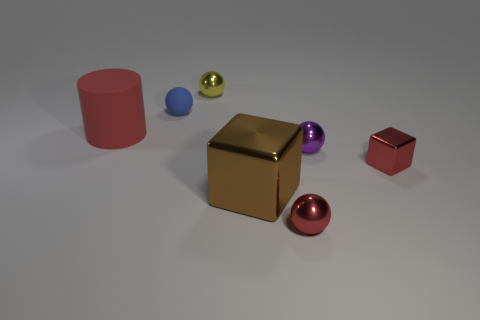Are there any other things that have the same shape as the red matte thing?
Your answer should be compact. No. Are there any brown objects behind the large cylinder?
Your answer should be compact. No. There is a large thing that is the same color as the tiny shiny cube; what is its shape?
Your answer should be very brief. Cylinder. What number of objects are spheres that are behind the red cylinder or purple metal things?
Ensure brevity in your answer.  3. What size is the brown cube that is the same material as the tiny red block?
Offer a very short reply. Large. There is a cylinder; is its size the same as the metal cube in front of the red block?
Give a very brief answer. Yes. What color is the object that is to the left of the yellow thing and to the right of the red rubber thing?
Offer a very short reply. Blue. What number of things are tiny metal spheres that are left of the red ball or objects in front of the small purple shiny ball?
Provide a succinct answer. 4. What is the color of the large thing that is on the right side of the ball that is left of the shiny object behind the tiny blue matte thing?
Provide a short and direct response. Brown. Are there any large brown metal things that have the same shape as the tiny blue thing?
Keep it short and to the point. No. 